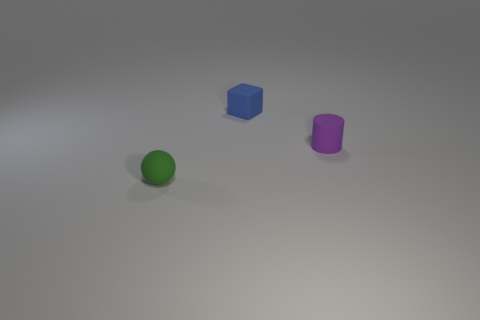How many other objects are the same color as the sphere?
Offer a terse response. 0. How many purple things are either cylinders or tiny rubber cubes?
Keep it short and to the point. 1. There is a tiny purple matte thing; does it have the same shape as the green thing that is in front of the rubber cylinder?
Keep it short and to the point. No. The tiny blue rubber thing is what shape?
Make the answer very short. Cube. How many objects are red balls or matte objects on the left side of the block?
Provide a short and direct response. 1. What is the shape of the small thing that is left of the tiny rubber object that is behind the small cylinder?
Keep it short and to the point. Sphere. Is there a blue matte cylinder that has the same size as the purple cylinder?
Offer a very short reply. No. There is a tiny matte sphere in front of the tiny rubber object behind the matte cylinder; what is its color?
Your response must be concise. Green. How many large brown balls are there?
Provide a succinct answer. 0. Are there fewer small matte blocks in front of the small purple object than tiny blue rubber things that are behind the blue object?
Your answer should be compact. No. 